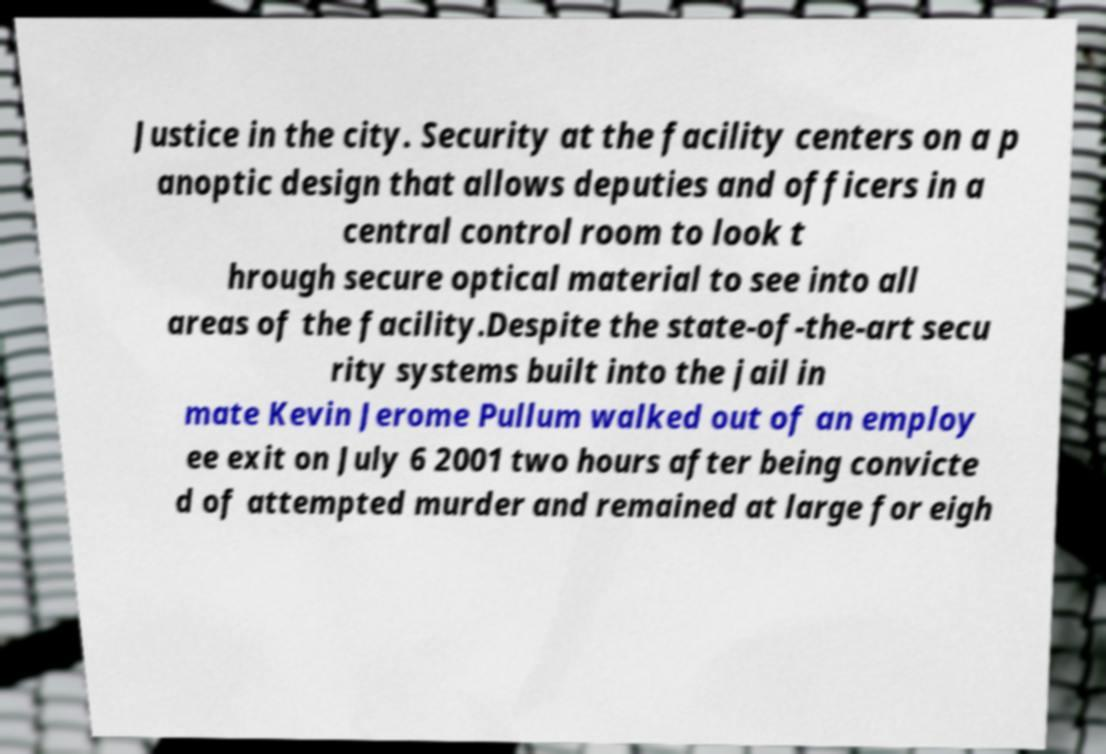Could you assist in decoding the text presented in this image and type it out clearly? Justice in the city. Security at the facility centers on a p anoptic design that allows deputies and officers in a central control room to look t hrough secure optical material to see into all areas of the facility.Despite the state-of-the-art secu rity systems built into the jail in mate Kevin Jerome Pullum walked out of an employ ee exit on July 6 2001 two hours after being convicte d of attempted murder and remained at large for eigh 